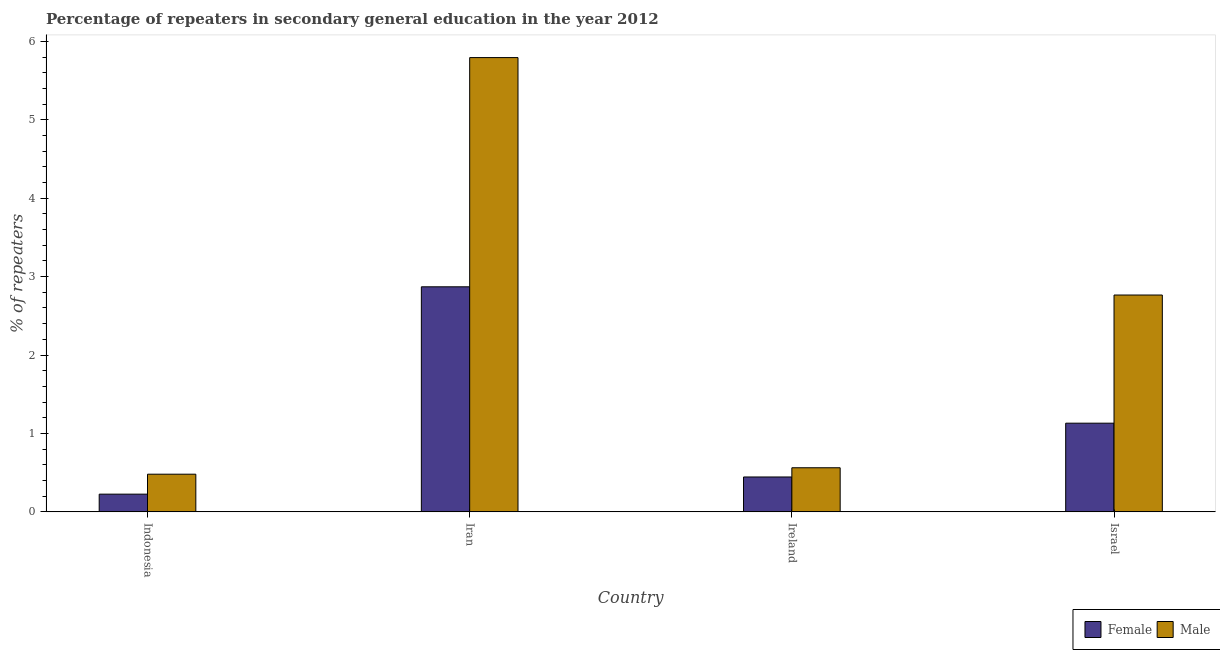How many different coloured bars are there?
Provide a short and direct response. 2. How many groups of bars are there?
Offer a terse response. 4. Are the number of bars per tick equal to the number of legend labels?
Your answer should be very brief. Yes. Are the number of bars on each tick of the X-axis equal?
Provide a succinct answer. Yes. How many bars are there on the 3rd tick from the right?
Your answer should be compact. 2. What is the percentage of female repeaters in Ireland?
Provide a short and direct response. 0.44. Across all countries, what is the maximum percentage of male repeaters?
Make the answer very short. 5.79. Across all countries, what is the minimum percentage of male repeaters?
Your response must be concise. 0.48. In which country was the percentage of male repeaters maximum?
Make the answer very short. Iran. In which country was the percentage of female repeaters minimum?
Keep it short and to the point. Indonesia. What is the total percentage of female repeaters in the graph?
Give a very brief answer. 4.67. What is the difference between the percentage of female repeaters in Indonesia and that in Iran?
Provide a short and direct response. -2.64. What is the difference between the percentage of female repeaters in Indonesia and the percentage of male repeaters in Ireland?
Offer a very short reply. -0.34. What is the average percentage of female repeaters per country?
Offer a very short reply. 1.17. What is the difference between the percentage of male repeaters and percentage of female repeaters in Indonesia?
Keep it short and to the point. 0.25. What is the ratio of the percentage of male repeaters in Indonesia to that in Israel?
Your answer should be compact. 0.17. Is the difference between the percentage of male repeaters in Iran and Ireland greater than the difference between the percentage of female repeaters in Iran and Ireland?
Offer a very short reply. Yes. What is the difference between the highest and the second highest percentage of female repeaters?
Your answer should be very brief. 1.74. What is the difference between the highest and the lowest percentage of male repeaters?
Offer a very short reply. 5.31. What does the 1st bar from the left in Indonesia represents?
Make the answer very short. Female. What does the 1st bar from the right in Israel represents?
Ensure brevity in your answer.  Male. How many bars are there?
Provide a short and direct response. 8. Are all the bars in the graph horizontal?
Ensure brevity in your answer.  No. Does the graph contain grids?
Offer a terse response. No. How many legend labels are there?
Your answer should be very brief. 2. What is the title of the graph?
Give a very brief answer. Percentage of repeaters in secondary general education in the year 2012. What is the label or title of the Y-axis?
Make the answer very short. % of repeaters. What is the % of repeaters in Female in Indonesia?
Your answer should be compact. 0.23. What is the % of repeaters of Male in Indonesia?
Ensure brevity in your answer.  0.48. What is the % of repeaters of Female in Iran?
Make the answer very short. 2.87. What is the % of repeaters of Male in Iran?
Your answer should be very brief. 5.79. What is the % of repeaters of Female in Ireland?
Provide a short and direct response. 0.44. What is the % of repeaters in Male in Ireland?
Provide a succinct answer. 0.56. What is the % of repeaters in Female in Israel?
Provide a short and direct response. 1.13. What is the % of repeaters of Male in Israel?
Offer a very short reply. 2.77. Across all countries, what is the maximum % of repeaters of Female?
Make the answer very short. 2.87. Across all countries, what is the maximum % of repeaters of Male?
Keep it short and to the point. 5.79. Across all countries, what is the minimum % of repeaters of Female?
Offer a very short reply. 0.23. Across all countries, what is the minimum % of repeaters of Male?
Provide a short and direct response. 0.48. What is the total % of repeaters of Female in the graph?
Your answer should be very brief. 4.67. What is the total % of repeaters of Male in the graph?
Your answer should be compact. 9.6. What is the difference between the % of repeaters in Female in Indonesia and that in Iran?
Offer a very short reply. -2.64. What is the difference between the % of repeaters of Male in Indonesia and that in Iran?
Offer a very short reply. -5.31. What is the difference between the % of repeaters in Female in Indonesia and that in Ireland?
Your answer should be very brief. -0.22. What is the difference between the % of repeaters of Male in Indonesia and that in Ireland?
Provide a succinct answer. -0.08. What is the difference between the % of repeaters in Female in Indonesia and that in Israel?
Offer a very short reply. -0.9. What is the difference between the % of repeaters in Male in Indonesia and that in Israel?
Keep it short and to the point. -2.28. What is the difference between the % of repeaters in Female in Iran and that in Ireland?
Your response must be concise. 2.43. What is the difference between the % of repeaters of Male in Iran and that in Ireland?
Make the answer very short. 5.23. What is the difference between the % of repeaters in Female in Iran and that in Israel?
Your answer should be very brief. 1.74. What is the difference between the % of repeaters of Male in Iran and that in Israel?
Keep it short and to the point. 3.03. What is the difference between the % of repeaters of Female in Ireland and that in Israel?
Your response must be concise. -0.69. What is the difference between the % of repeaters of Male in Ireland and that in Israel?
Ensure brevity in your answer.  -2.2. What is the difference between the % of repeaters of Female in Indonesia and the % of repeaters of Male in Iran?
Your response must be concise. -5.57. What is the difference between the % of repeaters of Female in Indonesia and the % of repeaters of Male in Ireland?
Your answer should be very brief. -0.34. What is the difference between the % of repeaters of Female in Indonesia and the % of repeaters of Male in Israel?
Keep it short and to the point. -2.54. What is the difference between the % of repeaters in Female in Iran and the % of repeaters in Male in Ireland?
Your response must be concise. 2.31. What is the difference between the % of repeaters of Female in Iran and the % of repeaters of Male in Israel?
Provide a succinct answer. 0.1. What is the difference between the % of repeaters of Female in Ireland and the % of repeaters of Male in Israel?
Your response must be concise. -2.32. What is the average % of repeaters of Female per country?
Offer a very short reply. 1.17. What is the average % of repeaters in Male per country?
Offer a terse response. 2.4. What is the difference between the % of repeaters in Female and % of repeaters in Male in Indonesia?
Keep it short and to the point. -0.25. What is the difference between the % of repeaters in Female and % of repeaters in Male in Iran?
Offer a very short reply. -2.92. What is the difference between the % of repeaters in Female and % of repeaters in Male in Ireland?
Ensure brevity in your answer.  -0.12. What is the difference between the % of repeaters in Female and % of repeaters in Male in Israel?
Your answer should be very brief. -1.63. What is the ratio of the % of repeaters of Female in Indonesia to that in Iran?
Give a very brief answer. 0.08. What is the ratio of the % of repeaters of Male in Indonesia to that in Iran?
Make the answer very short. 0.08. What is the ratio of the % of repeaters of Female in Indonesia to that in Ireland?
Your answer should be compact. 0.51. What is the ratio of the % of repeaters in Male in Indonesia to that in Ireland?
Your answer should be compact. 0.85. What is the ratio of the % of repeaters of Female in Indonesia to that in Israel?
Your answer should be compact. 0.2. What is the ratio of the % of repeaters in Male in Indonesia to that in Israel?
Your answer should be compact. 0.17. What is the ratio of the % of repeaters in Female in Iran to that in Ireland?
Provide a short and direct response. 6.45. What is the ratio of the % of repeaters in Male in Iran to that in Ireland?
Make the answer very short. 10.3. What is the ratio of the % of repeaters in Female in Iran to that in Israel?
Make the answer very short. 2.54. What is the ratio of the % of repeaters of Male in Iran to that in Israel?
Offer a terse response. 2.09. What is the ratio of the % of repeaters of Female in Ireland to that in Israel?
Offer a terse response. 0.39. What is the ratio of the % of repeaters of Male in Ireland to that in Israel?
Your answer should be compact. 0.2. What is the difference between the highest and the second highest % of repeaters in Female?
Keep it short and to the point. 1.74. What is the difference between the highest and the second highest % of repeaters of Male?
Offer a very short reply. 3.03. What is the difference between the highest and the lowest % of repeaters in Female?
Give a very brief answer. 2.64. What is the difference between the highest and the lowest % of repeaters of Male?
Provide a short and direct response. 5.31. 